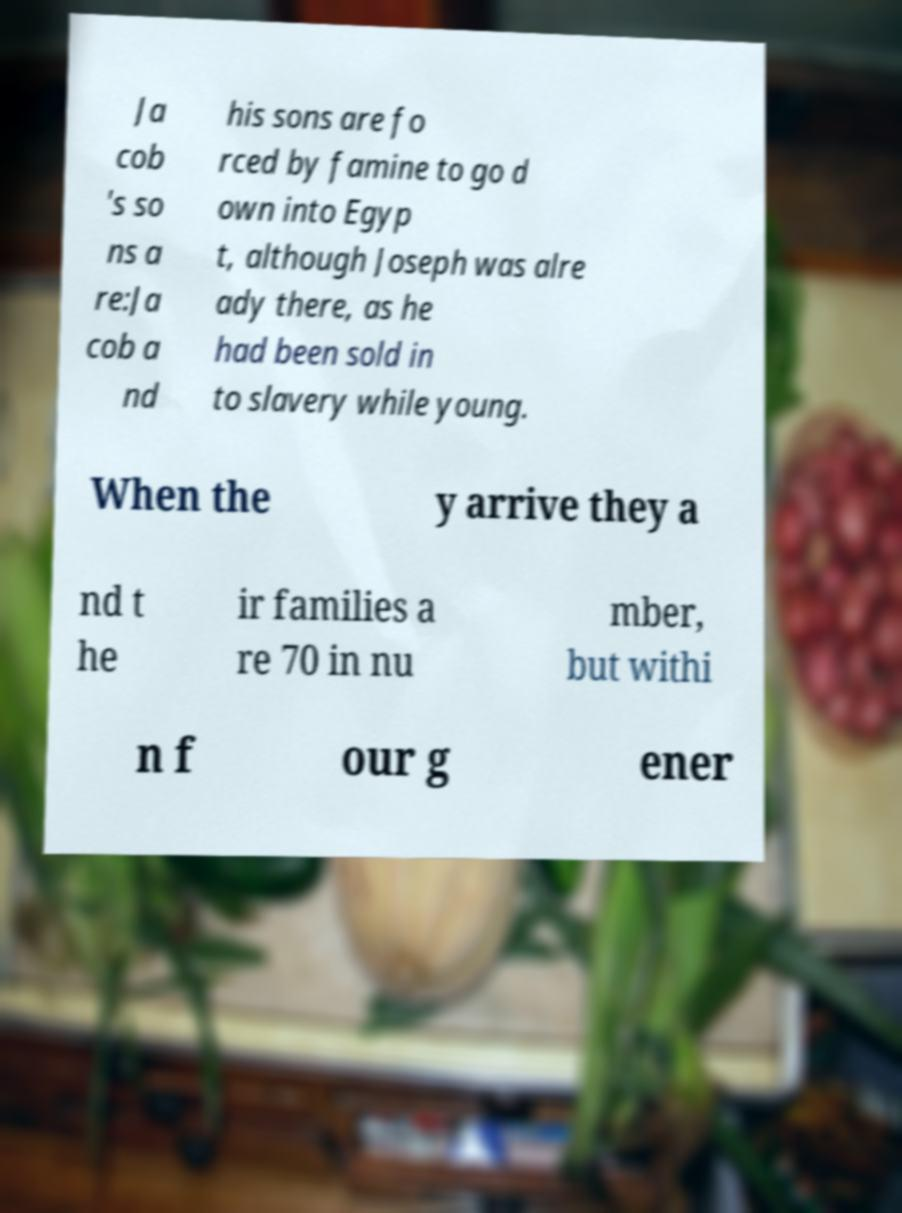Could you extract and type out the text from this image? Ja cob 's so ns a re:Ja cob a nd his sons are fo rced by famine to go d own into Egyp t, although Joseph was alre ady there, as he had been sold in to slavery while young. When the y arrive they a nd t he ir families a re 70 in nu mber, but withi n f our g ener 